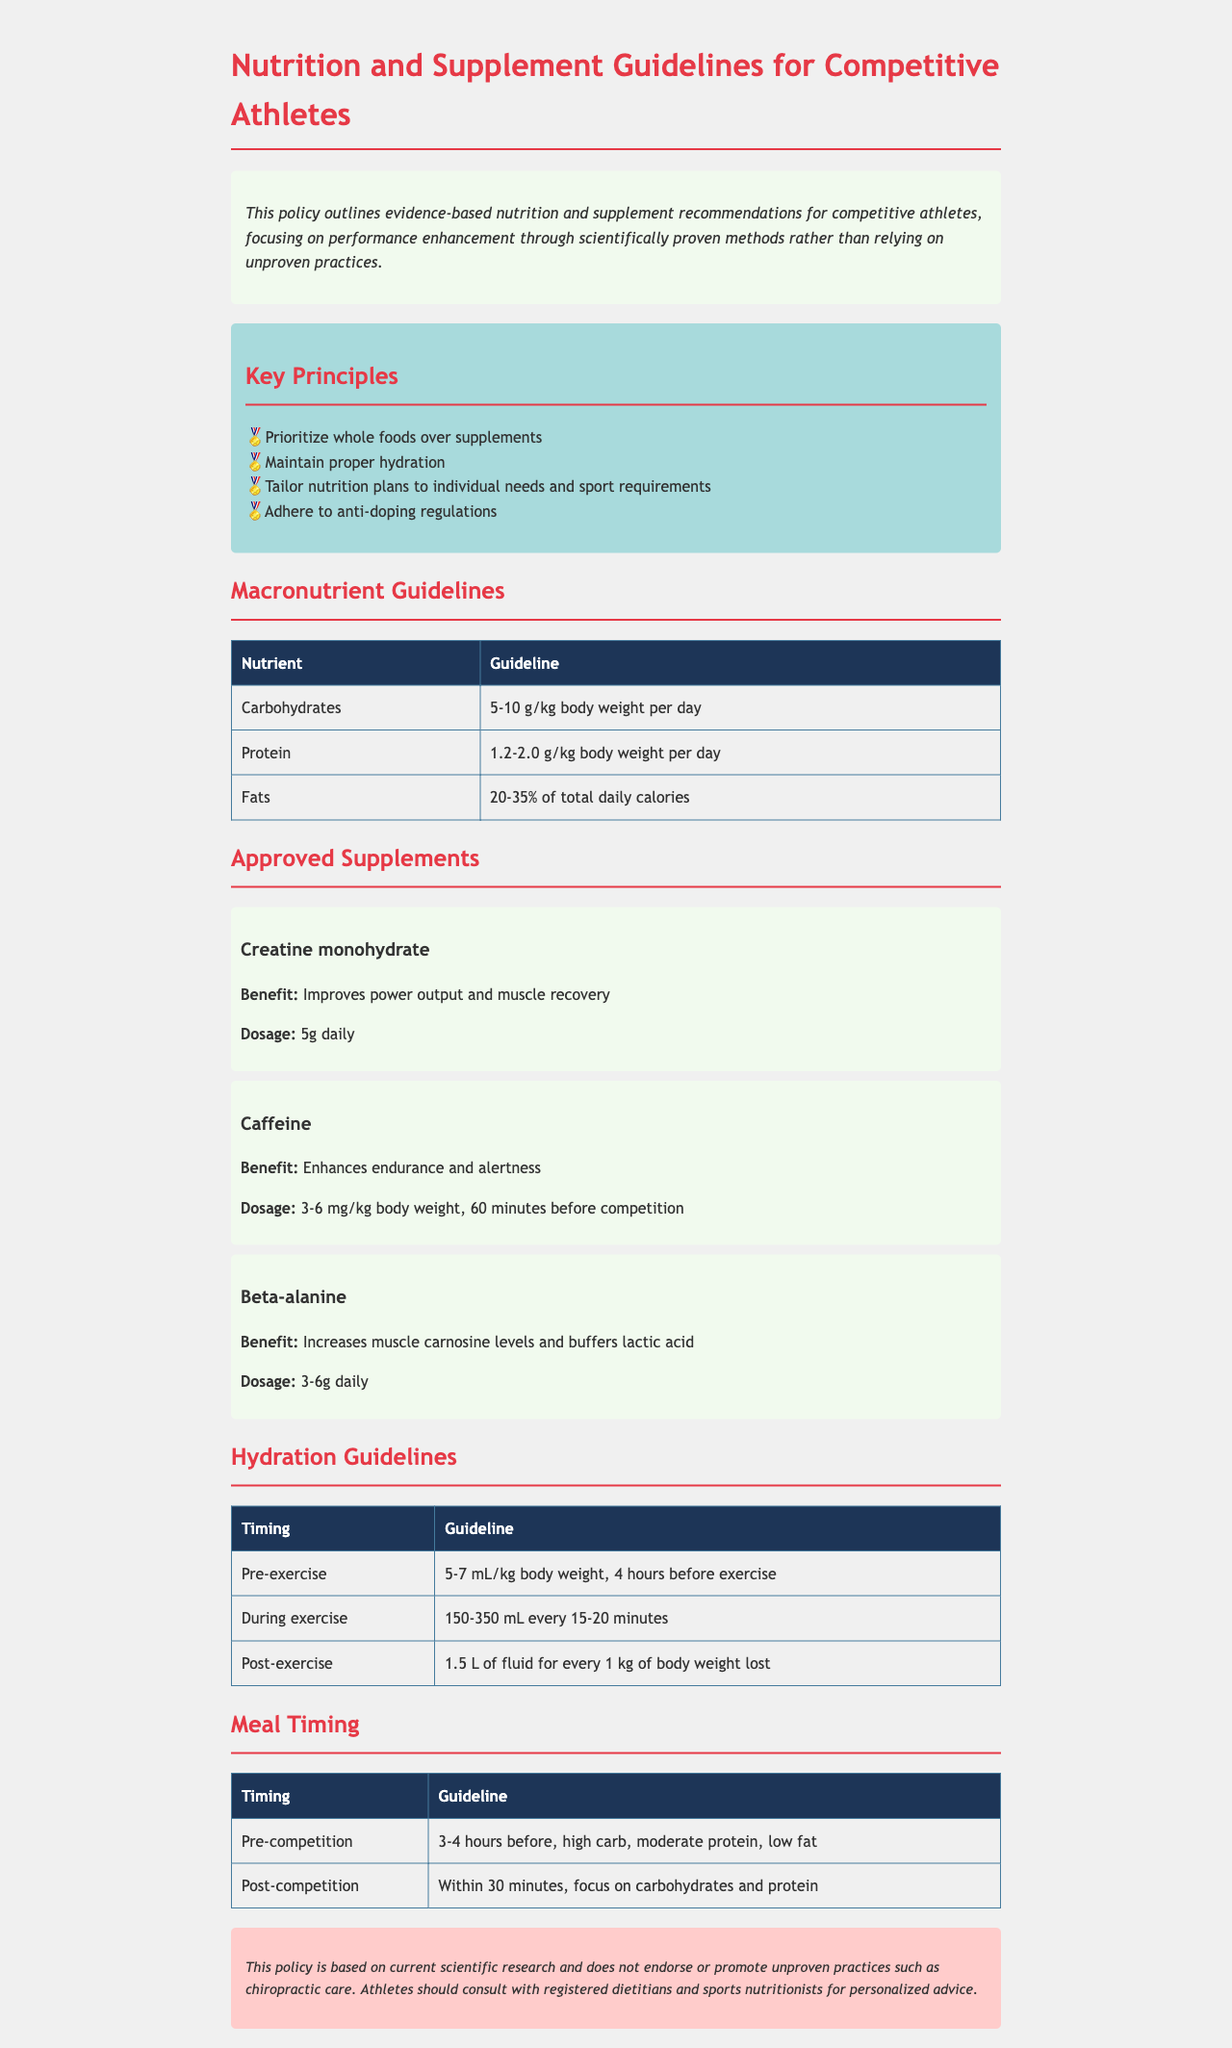What are the four key principles? The key principles outlined in the document are listed and can be found under "Key Principles".
Answer: Whole foods, hydration, tailored nutrition, anti-doping What is the carbohydrate guideline? The document specifies the carbohydrate guideline in the "Macronutrient Guidelines" section.
Answer: 5-10 g/kg body weight per day What is the recommended dosage for caffeine? The approved supplements section provides specific dosages for various supplements, including caffeine.
Answer: 3-6 mg/kg body weight, 60 minutes before competition What should be consumed post-competition? The meal timing guidelines indicate what to consume after competition.
Answer: Carbohydrates and protein What is the hydration recommendation during exercise? The "Hydration Guidelines" section states the hydration recommendation during exercise.
Answer: 150-350 mL every 15-20 minutes Which type of professionals should athletes consult for personalized advice? The disclaimer at the bottom of the document recommends consulting specific professionals for personalized nutrition advice.
Answer: Registered dietitians and sports nutritionists What percentage of total daily calories should fats comprise? The macronutrient guidelines specify the percentage of total daily calories for fats.
Answer: 20-35% What is emphasized over supplements according to the policy? The introduction of the document prioritizes certain dietary preferences.
Answer: Whole foods 